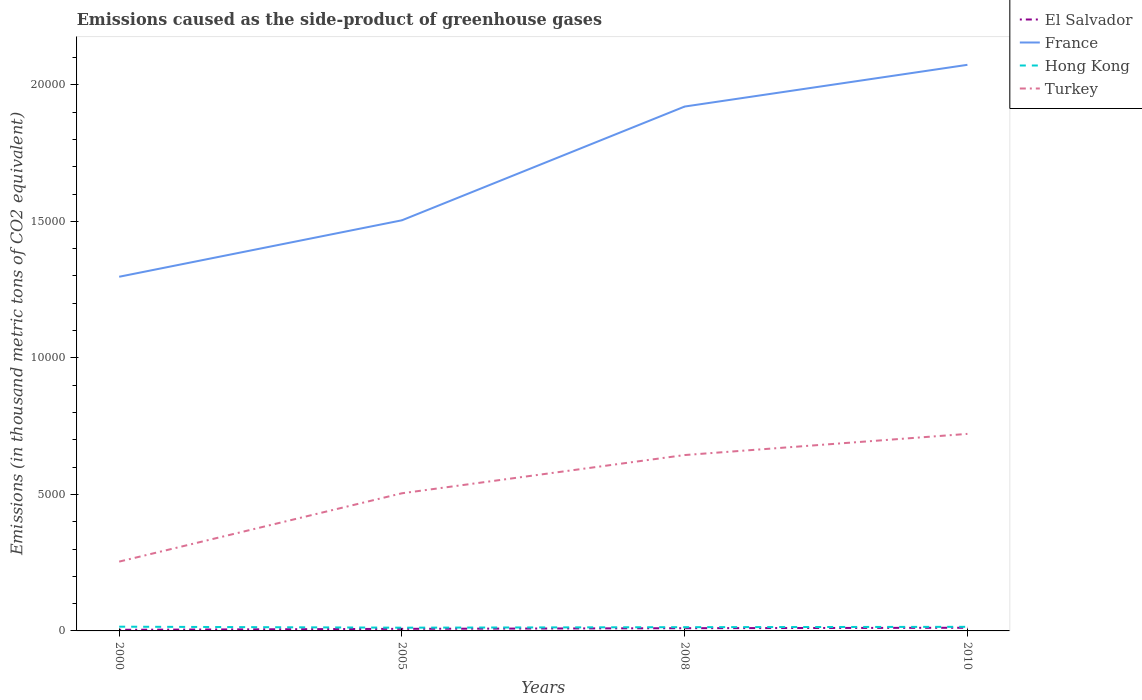Does the line corresponding to France intersect with the line corresponding to El Salvador?
Offer a terse response. No. Is the number of lines equal to the number of legend labels?
Provide a succinct answer. Yes. Across all years, what is the maximum emissions caused as the side-product of greenhouse gases in El Salvador?
Provide a short and direct response. 41.4. What is the total emissions caused as the side-product of greenhouse gases in Hong Kong in the graph?
Keep it short and to the point. 17.9. What is the difference between the highest and the second highest emissions caused as the side-product of greenhouse gases in Hong Kong?
Keep it short and to the point. 36.3. What is the difference between the highest and the lowest emissions caused as the side-product of greenhouse gases in France?
Make the answer very short. 2. How many lines are there?
Offer a very short reply. 4. How many years are there in the graph?
Ensure brevity in your answer.  4. What is the difference between two consecutive major ticks on the Y-axis?
Make the answer very short. 5000. Are the values on the major ticks of Y-axis written in scientific E-notation?
Provide a short and direct response. No. Does the graph contain grids?
Your answer should be very brief. No. Where does the legend appear in the graph?
Keep it short and to the point. Top right. What is the title of the graph?
Give a very brief answer. Emissions caused as the side-product of greenhouse gases. What is the label or title of the Y-axis?
Your response must be concise. Emissions (in thousand metric tons of CO2 equivalent). What is the Emissions (in thousand metric tons of CO2 equivalent) in El Salvador in 2000?
Keep it short and to the point. 41.4. What is the Emissions (in thousand metric tons of CO2 equivalent) in France in 2000?
Your answer should be very brief. 1.30e+04. What is the Emissions (in thousand metric tons of CO2 equivalent) in Hong Kong in 2000?
Give a very brief answer. 155.3. What is the Emissions (in thousand metric tons of CO2 equivalent) in Turkey in 2000?
Provide a short and direct response. 2538.5. What is the Emissions (in thousand metric tons of CO2 equivalent) of El Salvador in 2005?
Offer a terse response. 76.4. What is the Emissions (in thousand metric tons of CO2 equivalent) in France in 2005?
Your answer should be compact. 1.50e+04. What is the Emissions (in thousand metric tons of CO2 equivalent) in Hong Kong in 2005?
Offer a terse response. 119. What is the Emissions (in thousand metric tons of CO2 equivalent) of Turkey in 2005?
Your response must be concise. 5041.3. What is the Emissions (in thousand metric tons of CO2 equivalent) of El Salvador in 2008?
Make the answer very short. 99.6. What is the Emissions (in thousand metric tons of CO2 equivalent) of France in 2008?
Ensure brevity in your answer.  1.92e+04. What is the Emissions (in thousand metric tons of CO2 equivalent) in Hong Kong in 2008?
Your answer should be very brief. 137.4. What is the Emissions (in thousand metric tons of CO2 equivalent) of Turkey in 2008?
Ensure brevity in your answer.  6441. What is the Emissions (in thousand metric tons of CO2 equivalent) of El Salvador in 2010?
Give a very brief answer. 116. What is the Emissions (in thousand metric tons of CO2 equivalent) of France in 2010?
Give a very brief answer. 2.07e+04. What is the Emissions (in thousand metric tons of CO2 equivalent) in Hong Kong in 2010?
Keep it short and to the point. 150. What is the Emissions (in thousand metric tons of CO2 equivalent) of Turkey in 2010?
Offer a very short reply. 7216. Across all years, what is the maximum Emissions (in thousand metric tons of CO2 equivalent) in El Salvador?
Offer a terse response. 116. Across all years, what is the maximum Emissions (in thousand metric tons of CO2 equivalent) in France?
Your response must be concise. 2.07e+04. Across all years, what is the maximum Emissions (in thousand metric tons of CO2 equivalent) of Hong Kong?
Give a very brief answer. 155.3. Across all years, what is the maximum Emissions (in thousand metric tons of CO2 equivalent) in Turkey?
Your response must be concise. 7216. Across all years, what is the minimum Emissions (in thousand metric tons of CO2 equivalent) of El Salvador?
Offer a terse response. 41.4. Across all years, what is the minimum Emissions (in thousand metric tons of CO2 equivalent) of France?
Your answer should be very brief. 1.30e+04. Across all years, what is the minimum Emissions (in thousand metric tons of CO2 equivalent) of Hong Kong?
Offer a very short reply. 119. Across all years, what is the minimum Emissions (in thousand metric tons of CO2 equivalent) in Turkey?
Your answer should be very brief. 2538.5. What is the total Emissions (in thousand metric tons of CO2 equivalent) of El Salvador in the graph?
Offer a very short reply. 333.4. What is the total Emissions (in thousand metric tons of CO2 equivalent) in France in the graph?
Keep it short and to the point. 6.79e+04. What is the total Emissions (in thousand metric tons of CO2 equivalent) in Hong Kong in the graph?
Ensure brevity in your answer.  561.7. What is the total Emissions (in thousand metric tons of CO2 equivalent) of Turkey in the graph?
Give a very brief answer. 2.12e+04. What is the difference between the Emissions (in thousand metric tons of CO2 equivalent) of El Salvador in 2000 and that in 2005?
Keep it short and to the point. -35. What is the difference between the Emissions (in thousand metric tons of CO2 equivalent) in France in 2000 and that in 2005?
Offer a terse response. -2068. What is the difference between the Emissions (in thousand metric tons of CO2 equivalent) in Hong Kong in 2000 and that in 2005?
Give a very brief answer. 36.3. What is the difference between the Emissions (in thousand metric tons of CO2 equivalent) in Turkey in 2000 and that in 2005?
Give a very brief answer. -2502.8. What is the difference between the Emissions (in thousand metric tons of CO2 equivalent) in El Salvador in 2000 and that in 2008?
Offer a terse response. -58.2. What is the difference between the Emissions (in thousand metric tons of CO2 equivalent) in France in 2000 and that in 2008?
Ensure brevity in your answer.  -6233.8. What is the difference between the Emissions (in thousand metric tons of CO2 equivalent) of Turkey in 2000 and that in 2008?
Your answer should be very brief. -3902.5. What is the difference between the Emissions (in thousand metric tons of CO2 equivalent) of El Salvador in 2000 and that in 2010?
Make the answer very short. -74.6. What is the difference between the Emissions (in thousand metric tons of CO2 equivalent) of France in 2000 and that in 2010?
Provide a succinct answer. -7761.8. What is the difference between the Emissions (in thousand metric tons of CO2 equivalent) in Hong Kong in 2000 and that in 2010?
Provide a short and direct response. 5.3. What is the difference between the Emissions (in thousand metric tons of CO2 equivalent) in Turkey in 2000 and that in 2010?
Provide a succinct answer. -4677.5. What is the difference between the Emissions (in thousand metric tons of CO2 equivalent) in El Salvador in 2005 and that in 2008?
Give a very brief answer. -23.2. What is the difference between the Emissions (in thousand metric tons of CO2 equivalent) of France in 2005 and that in 2008?
Provide a succinct answer. -4165.8. What is the difference between the Emissions (in thousand metric tons of CO2 equivalent) of Hong Kong in 2005 and that in 2008?
Give a very brief answer. -18.4. What is the difference between the Emissions (in thousand metric tons of CO2 equivalent) in Turkey in 2005 and that in 2008?
Offer a very short reply. -1399.7. What is the difference between the Emissions (in thousand metric tons of CO2 equivalent) in El Salvador in 2005 and that in 2010?
Ensure brevity in your answer.  -39.6. What is the difference between the Emissions (in thousand metric tons of CO2 equivalent) in France in 2005 and that in 2010?
Your response must be concise. -5693.8. What is the difference between the Emissions (in thousand metric tons of CO2 equivalent) of Hong Kong in 2005 and that in 2010?
Keep it short and to the point. -31. What is the difference between the Emissions (in thousand metric tons of CO2 equivalent) in Turkey in 2005 and that in 2010?
Keep it short and to the point. -2174.7. What is the difference between the Emissions (in thousand metric tons of CO2 equivalent) of El Salvador in 2008 and that in 2010?
Offer a terse response. -16.4. What is the difference between the Emissions (in thousand metric tons of CO2 equivalent) of France in 2008 and that in 2010?
Offer a very short reply. -1528. What is the difference between the Emissions (in thousand metric tons of CO2 equivalent) in Hong Kong in 2008 and that in 2010?
Keep it short and to the point. -12.6. What is the difference between the Emissions (in thousand metric tons of CO2 equivalent) of Turkey in 2008 and that in 2010?
Give a very brief answer. -775. What is the difference between the Emissions (in thousand metric tons of CO2 equivalent) of El Salvador in 2000 and the Emissions (in thousand metric tons of CO2 equivalent) of France in 2005?
Provide a short and direct response. -1.50e+04. What is the difference between the Emissions (in thousand metric tons of CO2 equivalent) of El Salvador in 2000 and the Emissions (in thousand metric tons of CO2 equivalent) of Hong Kong in 2005?
Your answer should be very brief. -77.6. What is the difference between the Emissions (in thousand metric tons of CO2 equivalent) in El Salvador in 2000 and the Emissions (in thousand metric tons of CO2 equivalent) in Turkey in 2005?
Provide a succinct answer. -4999.9. What is the difference between the Emissions (in thousand metric tons of CO2 equivalent) of France in 2000 and the Emissions (in thousand metric tons of CO2 equivalent) of Hong Kong in 2005?
Offer a very short reply. 1.29e+04. What is the difference between the Emissions (in thousand metric tons of CO2 equivalent) in France in 2000 and the Emissions (in thousand metric tons of CO2 equivalent) in Turkey in 2005?
Your answer should be compact. 7929.9. What is the difference between the Emissions (in thousand metric tons of CO2 equivalent) in Hong Kong in 2000 and the Emissions (in thousand metric tons of CO2 equivalent) in Turkey in 2005?
Your answer should be compact. -4886. What is the difference between the Emissions (in thousand metric tons of CO2 equivalent) in El Salvador in 2000 and the Emissions (in thousand metric tons of CO2 equivalent) in France in 2008?
Your answer should be compact. -1.92e+04. What is the difference between the Emissions (in thousand metric tons of CO2 equivalent) in El Salvador in 2000 and the Emissions (in thousand metric tons of CO2 equivalent) in Hong Kong in 2008?
Your response must be concise. -96. What is the difference between the Emissions (in thousand metric tons of CO2 equivalent) of El Salvador in 2000 and the Emissions (in thousand metric tons of CO2 equivalent) of Turkey in 2008?
Give a very brief answer. -6399.6. What is the difference between the Emissions (in thousand metric tons of CO2 equivalent) of France in 2000 and the Emissions (in thousand metric tons of CO2 equivalent) of Hong Kong in 2008?
Your answer should be very brief. 1.28e+04. What is the difference between the Emissions (in thousand metric tons of CO2 equivalent) in France in 2000 and the Emissions (in thousand metric tons of CO2 equivalent) in Turkey in 2008?
Give a very brief answer. 6530.2. What is the difference between the Emissions (in thousand metric tons of CO2 equivalent) of Hong Kong in 2000 and the Emissions (in thousand metric tons of CO2 equivalent) of Turkey in 2008?
Give a very brief answer. -6285.7. What is the difference between the Emissions (in thousand metric tons of CO2 equivalent) in El Salvador in 2000 and the Emissions (in thousand metric tons of CO2 equivalent) in France in 2010?
Ensure brevity in your answer.  -2.07e+04. What is the difference between the Emissions (in thousand metric tons of CO2 equivalent) of El Salvador in 2000 and the Emissions (in thousand metric tons of CO2 equivalent) of Hong Kong in 2010?
Offer a terse response. -108.6. What is the difference between the Emissions (in thousand metric tons of CO2 equivalent) in El Salvador in 2000 and the Emissions (in thousand metric tons of CO2 equivalent) in Turkey in 2010?
Give a very brief answer. -7174.6. What is the difference between the Emissions (in thousand metric tons of CO2 equivalent) of France in 2000 and the Emissions (in thousand metric tons of CO2 equivalent) of Hong Kong in 2010?
Provide a succinct answer. 1.28e+04. What is the difference between the Emissions (in thousand metric tons of CO2 equivalent) in France in 2000 and the Emissions (in thousand metric tons of CO2 equivalent) in Turkey in 2010?
Give a very brief answer. 5755.2. What is the difference between the Emissions (in thousand metric tons of CO2 equivalent) of Hong Kong in 2000 and the Emissions (in thousand metric tons of CO2 equivalent) of Turkey in 2010?
Ensure brevity in your answer.  -7060.7. What is the difference between the Emissions (in thousand metric tons of CO2 equivalent) of El Salvador in 2005 and the Emissions (in thousand metric tons of CO2 equivalent) of France in 2008?
Provide a succinct answer. -1.91e+04. What is the difference between the Emissions (in thousand metric tons of CO2 equivalent) of El Salvador in 2005 and the Emissions (in thousand metric tons of CO2 equivalent) of Hong Kong in 2008?
Make the answer very short. -61. What is the difference between the Emissions (in thousand metric tons of CO2 equivalent) in El Salvador in 2005 and the Emissions (in thousand metric tons of CO2 equivalent) in Turkey in 2008?
Give a very brief answer. -6364.6. What is the difference between the Emissions (in thousand metric tons of CO2 equivalent) of France in 2005 and the Emissions (in thousand metric tons of CO2 equivalent) of Hong Kong in 2008?
Provide a succinct answer. 1.49e+04. What is the difference between the Emissions (in thousand metric tons of CO2 equivalent) of France in 2005 and the Emissions (in thousand metric tons of CO2 equivalent) of Turkey in 2008?
Provide a short and direct response. 8598.2. What is the difference between the Emissions (in thousand metric tons of CO2 equivalent) of Hong Kong in 2005 and the Emissions (in thousand metric tons of CO2 equivalent) of Turkey in 2008?
Your answer should be compact. -6322. What is the difference between the Emissions (in thousand metric tons of CO2 equivalent) of El Salvador in 2005 and the Emissions (in thousand metric tons of CO2 equivalent) of France in 2010?
Provide a short and direct response. -2.07e+04. What is the difference between the Emissions (in thousand metric tons of CO2 equivalent) of El Salvador in 2005 and the Emissions (in thousand metric tons of CO2 equivalent) of Hong Kong in 2010?
Give a very brief answer. -73.6. What is the difference between the Emissions (in thousand metric tons of CO2 equivalent) of El Salvador in 2005 and the Emissions (in thousand metric tons of CO2 equivalent) of Turkey in 2010?
Offer a terse response. -7139.6. What is the difference between the Emissions (in thousand metric tons of CO2 equivalent) in France in 2005 and the Emissions (in thousand metric tons of CO2 equivalent) in Hong Kong in 2010?
Provide a succinct answer. 1.49e+04. What is the difference between the Emissions (in thousand metric tons of CO2 equivalent) of France in 2005 and the Emissions (in thousand metric tons of CO2 equivalent) of Turkey in 2010?
Your response must be concise. 7823.2. What is the difference between the Emissions (in thousand metric tons of CO2 equivalent) of Hong Kong in 2005 and the Emissions (in thousand metric tons of CO2 equivalent) of Turkey in 2010?
Offer a very short reply. -7097. What is the difference between the Emissions (in thousand metric tons of CO2 equivalent) in El Salvador in 2008 and the Emissions (in thousand metric tons of CO2 equivalent) in France in 2010?
Your answer should be very brief. -2.06e+04. What is the difference between the Emissions (in thousand metric tons of CO2 equivalent) in El Salvador in 2008 and the Emissions (in thousand metric tons of CO2 equivalent) in Hong Kong in 2010?
Ensure brevity in your answer.  -50.4. What is the difference between the Emissions (in thousand metric tons of CO2 equivalent) in El Salvador in 2008 and the Emissions (in thousand metric tons of CO2 equivalent) in Turkey in 2010?
Offer a very short reply. -7116.4. What is the difference between the Emissions (in thousand metric tons of CO2 equivalent) of France in 2008 and the Emissions (in thousand metric tons of CO2 equivalent) of Hong Kong in 2010?
Keep it short and to the point. 1.91e+04. What is the difference between the Emissions (in thousand metric tons of CO2 equivalent) in France in 2008 and the Emissions (in thousand metric tons of CO2 equivalent) in Turkey in 2010?
Your answer should be compact. 1.20e+04. What is the difference between the Emissions (in thousand metric tons of CO2 equivalent) of Hong Kong in 2008 and the Emissions (in thousand metric tons of CO2 equivalent) of Turkey in 2010?
Offer a very short reply. -7078.6. What is the average Emissions (in thousand metric tons of CO2 equivalent) of El Salvador per year?
Make the answer very short. 83.35. What is the average Emissions (in thousand metric tons of CO2 equivalent) of France per year?
Your answer should be very brief. 1.70e+04. What is the average Emissions (in thousand metric tons of CO2 equivalent) in Hong Kong per year?
Keep it short and to the point. 140.43. What is the average Emissions (in thousand metric tons of CO2 equivalent) in Turkey per year?
Provide a succinct answer. 5309.2. In the year 2000, what is the difference between the Emissions (in thousand metric tons of CO2 equivalent) in El Salvador and Emissions (in thousand metric tons of CO2 equivalent) in France?
Offer a very short reply. -1.29e+04. In the year 2000, what is the difference between the Emissions (in thousand metric tons of CO2 equivalent) of El Salvador and Emissions (in thousand metric tons of CO2 equivalent) of Hong Kong?
Make the answer very short. -113.9. In the year 2000, what is the difference between the Emissions (in thousand metric tons of CO2 equivalent) in El Salvador and Emissions (in thousand metric tons of CO2 equivalent) in Turkey?
Offer a terse response. -2497.1. In the year 2000, what is the difference between the Emissions (in thousand metric tons of CO2 equivalent) of France and Emissions (in thousand metric tons of CO2 equivalent) of Hong Kong?
Ensure brevity in your answer.  1.28e+04. In the year 2000, what is the difference between the Emissions (in thousand metric tons of CO2 equivalent) in France and Emissions (in thousand metric tons of CO2 equivalent) in Turkey?
Your answer should be very brief. 1.04e+04. In the year 2000, what is the difference between the Emissions (in thousand metric tons of CO2 equivalent) of Hong Kong and Emissions (in thousand metric tons of CO2 equivalent) of Turkey?
Ensure brevity in your answer.  -2383.2. In the year 2005, what is the difference between the Emissions (in thousand metric tons of CO2 equivalent) of El Salvador and Emissions (in thousand metric tons of CO2 equivalent) of France?
Make the answer very short. -1.50e+04. In the year 2005, what is the difference between the Emissions (in thousand metric tons of CO2 equivalent) in El Salvador and Emissions (in thousand metric tons of CO2 equivalent) in Hong Kong?
Keep it short and to the point. -42.6. In the year 2005, what is the difference between the Emissions (in thousand metric tons of CO2 equivalent) of El Salvador and Emissions (in thousand metric tons of CO2 equivalent) of Turkey?
Provide a succinct answer. -4964.9. In the year 2005, what is the difference between the Emissions (in thousand metric tons of CO2 equivalent) in France and Emissions (in thousand metric tons of CO2 equivalent) in Hong Kong?
Keep it short and to the point. 1.49e+04. In the year 2005, what is the difference between the Emissions (in thousand metric tons of CO2 equivalent) of France and Emissions (in thousand metric tons of CO2 equivalent) of Turkey?
Provide a short and direct response. 9997.9. In the year 2005, what is the difference between the Emissions (in thousand metric tons of CO2 equivalent) of Hong Kong and Emissions (in thousand metric tons of CO2 equivalent) of Turkey?
Ensure brevity in your answer.  -4922.3. In the year 2008, what is the difference between the Emissions (in thousand metric tons of CO2 equivalent) of El Salvador and Emissions (in thousand metric tons of CO2 equivalent) of France?
Your answer should be very brief. -1.91e+04. In the year 2008, what is the difference between the Emissions (in thousand metric tons of CO2 equivalent) of El Salvador and Emissions (in thousand metric tons of CO2 equivalent) of Hong Kong?
Offer a terse response. -37.8. In the year 2008, what is the difference between the Emissions (in thousand metric tons of CO2 equivalent) in El Salvador and Emissions (in thousand metric tons of CO2 equivalent) in Turkey?
Provide a succinct answer. -6341.4. In the year 2008, what is the difference between the Emissions (in thousand metric tons of CO2 equivalent) of France and Emissions (in thousand metric tons of CO2 equivalent) of Hong Kong?
Your answer should be compact. 1.91e+04. In the year 2008, what is the difference between the Emissions (in thousand metric tons of CO2 equivalent) in France and Emissions (in thousand metric tons of CO2 equivalent) in Turkey?
Keep it short and to the point. 1.28e+04. In the year 2008, what is the difference between the Emissions (in thousand metric tons of CO2 equivalent) in Hong Kong and Emissions (in thousand metric tons of CO2 equivalent) in Turkey?
Give a very brief answer. -6303.6. In the year 2010, what is the difference between the Emissions (in thousand metric tons of CO2 equivalent) of El Salvador and Emissions (in thousand metric tons of CO2 equivalent) of France?
Provide a succinct answer. -2.06e+04. In the year 2010, what is the difference between the Emissions (in thousand metric tons of CO2 equivalent) of El Salvador and Emissions (in thousand metric tons of CO2 equivalent) of Hong Kong?
Keep it short and to the point. -34. In the year 2010, what is the difference between the Emissions (in thousand metric tons of CO2 equivalent) in El Salvador and Emissions (in thousand metric tons of CO2 equivalent) in Turkey?
Provide a succinct answer. -7100. In the year 2010, what is the difference between the Emissions (in thousand metric tons of CO2 equivalent) in France and Emissions (in thousand metric tons of CO2 equivalent) in Hong Kong?
Your answer should be very brief. 2.06e+04. In the year 2010, what is the difference between the Emissions (in thousand metric tons of CO2 equivalent) in France and Emissions (in thousand metric tons of CO2 equivalent) in Turkey?
Offer a terse response. 1.35e+04. In the year 2010, what is the difference between the Emissions (in thousand metric tons of CO2 equivalent) of Hong Kong and Emissions (in thousand metric tons of CO2 equivalent) of Turkey?
Ensure brevity in your answer.  -7066. What is the ratio of the Emissions (in thousand metric tons of CO2 equivalent) in El Salvador in 2000 to that in 2005?
Ensure brevity in your answer.  0.54. What is the ratio of the Emissions (in thousand metric tons of CO2 equivalent) of France in 2000 to that in 2005?
Offer a very short reply. 0.86. What is the ratio of the Emissions (in thousand metric tons of CO2 equivalent) in Hong Kong in 2000 to that in 2005?
Give a very brief answer. 1.3. What is the ratio of the Emissions (in thousand metric tons of CO2 equivalent) in Turkey in 2000 to that in 2005?
Keep it short and to the point. 0.5. What is the ratio of the Emissions (in thousand metric tons of CO2 equivalent) of El Salvador in 2000 to that in 2008?
Provide a short and direct response. 0.42. What is the ratio of the Emissions (in thousand metric tons of CO2 equivalent) of France in 2000 to that in 2008?
Offer a very short reply. 0.68. What is the ratio of the Emissions (in thousand metric tons of CO2 equivalent) in Hong Kong in 2000 to that in 2008?
Provide a short and direct response. 1.13. What is the ratio of the Emissions (in thousand metric tons of CO2 equivalent) of Turkey in 2000 to that in 2008?
Provide a short and direct response. 0.39. What is the ratio of the Emissions (in thousand metric tons of CO2 equivalent) of El Salvador in 2000 to that in 2010?
Offer a terse response. 0.36. What is the ratio of the Emissions (in thousand metric tons of CO2 equivalent) in France in 2000 to that in 2010?
Provide a succinct answer. 0.63. What is the ratio of the Emissions (in thousand metric tons of CO2 equivalent) in Hong Kong in 2000 to that in 2010?
Provide a short and direct response. 1.04. What is the ratio of the Emissions (in thousand metric tons of CO2 equivalent) in Turkey in 2000 to that in 2010?
Offer a terse response. 0.35. What is the ratio of the Emissions (in thousand metric tons of CO2 equivalent) in El Salvador in 2005 to that in 2008?
Provide a short and direct response. 0.77. What is the ratio of the Emissions (in thousand metric tons of CO2 equivalent) in France in 2005 to that in 2008?
Provide a short and direct response. 0.78. What is the ratio of the Emissions (in thousand metric tons of CO2 equivalent) of Hong Kong in 2005 to that in 2008?
Your response must be concise. 0.87. What is the ratio of the Emissions (in thousand metric tons of CO2 equivalent) in Turkey in 2005 to that in 2008?
Give a very brief answer. 0.78. What is the ratio of the Emissions (in thousand metric tons of CO2 equivalent) in El Salvador in 2005 to that in 2010?
Offer a terse response. 0.66. What is the ratio of the Emissions (in thousand metric tons of CO2 equivalent) in France in 2005 to that in 2010?
Keep it short and to the point. 0.73. What is the ratio of the Emissions (in thousand metric tons of CO2 equivalent) in Hong Kong in 2005 to that in 2010?
Offer a terse response. 0.79. What is the ratio of the Emissions (in thousand metric tons of CO2 equivalent) of Turkey in 2005 to that in 2010?
Offer a very short reply. 0.7. What is the ratio of the Emissions (in thousand metric tons of CO2 equivalent) of El Salvador in 2008 to that in 2010?
Your answer should be very brief. 0.86. What is the ratio of the Emissions (in thousand metric tons of CO2 equivalent) in France in 2008 to that in 2010?
Give a very brief answer. 0.93. What is the ratio of the Emissions (in thousand metric tons of CO2 equivalent) of Hong Kong in 2008 to that in 2010?
Ensure brevity in your answer.  0.92. What is the ratio of the Emissions (in thousand metric tons of CO2 equivalent) of Turkey in 2008 to that in 2010?
Your answer should be compact. 0.89. What is the difference between the highest and the second highest Emissions (in thousand metric tons of CO2 equivalent) in El Salvador?
Give a very brief answer. 16.4. What is the difference between the highest and the second highest Emissions (in thousand metric tons of CO2 equivalent) of France?
Provide a short and direct response. 1528. What is the difference between the highest and the second highest Emissions (in thousand metric tons of CO2 equivalent) of Hong Kong?
Offer a very short reply. 5.3. What is the difference between the highest and the second highest Emissions (in thousand metric tons of CO2 equivalent) in Turkey?
Provide a short and direct response. 775. What is the difference between the highest and the lowest Emissions (in thousand metric tons of CO2 equivalent) of El Salvador?
Your answer should be very brief. 74.6. What is the difference between the highest and the lowest Emissions (in thousand metric tons of CO2 equivalent) in France?
Provide a short and direct response. 7761.8. What is the difference between the highest and the lowest Emissions (in thousand metric tons of CO2 equivalent) in Hong Kong?
Your answer should be very brief. 36.3. What is the difference between the highest and the lowest Emissions (in thousand metric tons of CO2 equivalent) of Turkey?
Your answer should be very brief. 4677.5. 